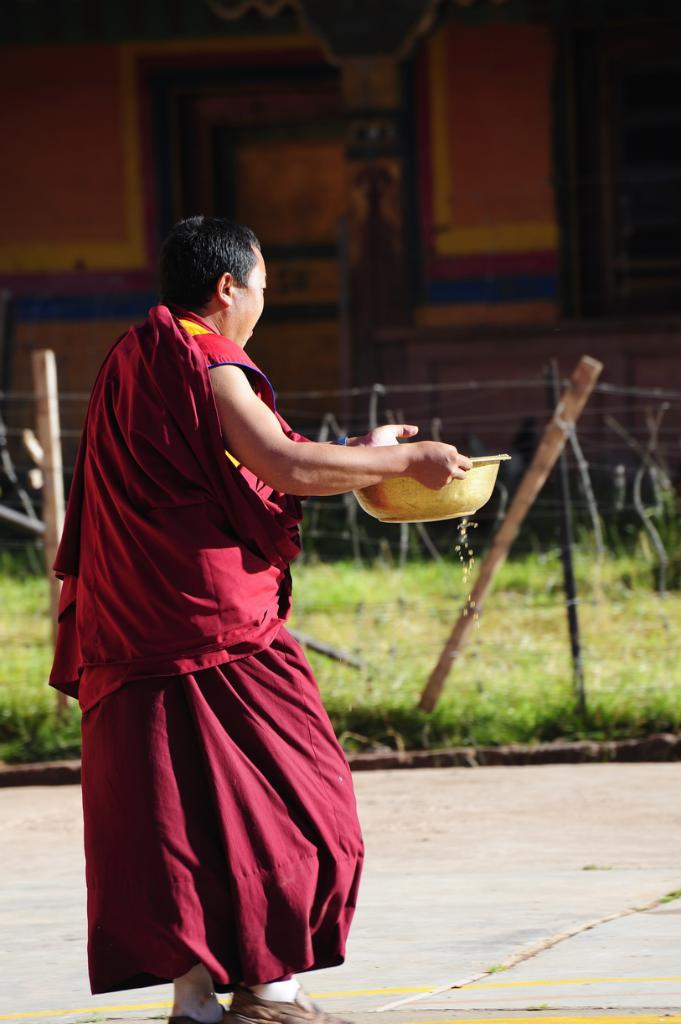Who is present in the image? There is a man in the image. What is the man holding in the image? The man is carrying a vessel in the image. What can be seen in the background of the image? There is a fence, green land, and a wall visible in the background of the image. What type of eggnog is being served in the image? There is no eggnog present in the image; it features a man carrying a vessel in front of a fence, green land, and a wall. 